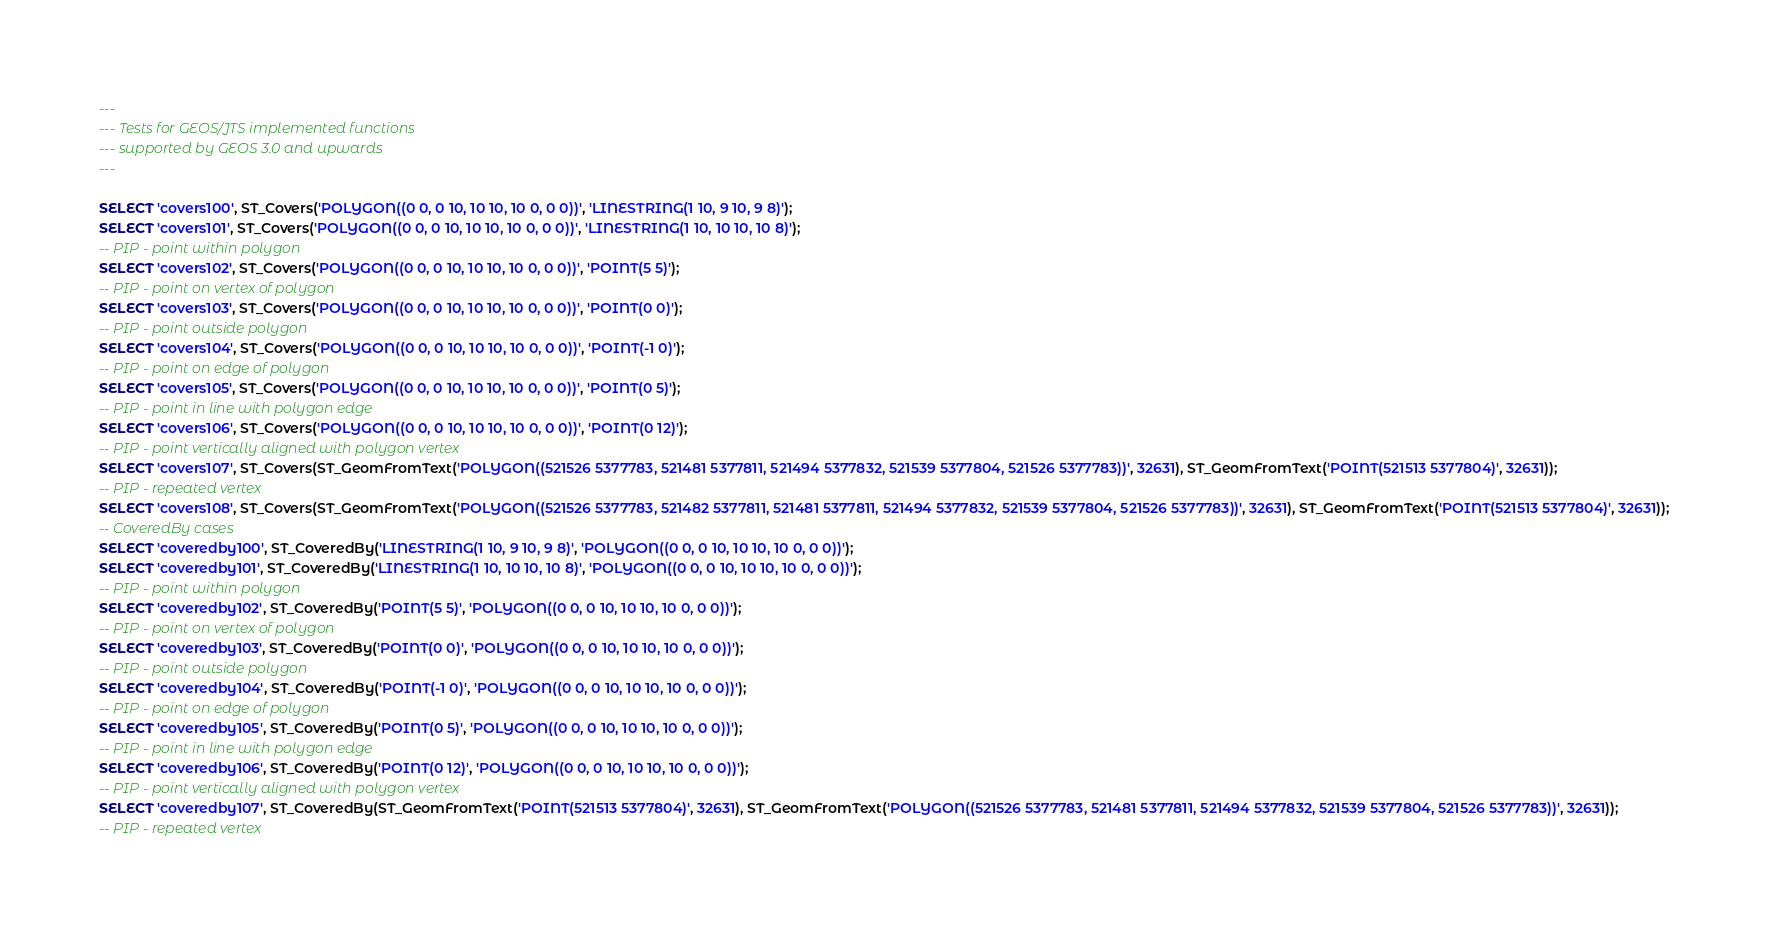Convert code to text. <code><loc_0><loc_0><loc_500><loc_500><_SQL_>---
--- Tests for GEOS/JTS implemented functions
--- supported by GEOS 3.0 and upwards
---

SELECT 'covers100', ST_Covers('POLYGON((0 0, 0 10, 10 10, 10 0, 0 0))', 'LINESTRING(1 10, 9 10, 9 8)');
SELECT 'covers101', ST_Covers('POLYGON((0 0, 0 10, 10 10, 10 0, 0 0))', 'LINESTRING(1 10, 10 10, 10 8)');
-- PIP - point within polygon
SELECT 'covers102', ST_Covers('POLYGON((0 0, 0 10, 10 10, 10 0, 0 0))', 'POINT(5 5)');
-- PIP - point on vertex of polygon
SELECT 'covers103', ST_Covers('POLYGON((0 0, 0 10, 10 10, 10 0, 0 0))', 'POINT(0 0)');
-- PIP - point outside polygon
SELECT 'covers104', ST_Covers('POLYGON((0 0, 0 10, 10 10, 10 0, 0 0))', 'POINT(-1 0)');
-- PIP - point on edge of polygon
SELECT 'covers105', ST_Covers('POLYGON((0 0, 0 10, 10 10, 10 0, 0 0))', 'POINT(0 5)');
-- PIP - point in line with polygon edge
SELECT 'covers106', ST_Covers('POLYGON((0 0, 0 10, 10 10, 10 0, 0 0))', 'POINT(0 12)');
-- PIP - point vertically aligned with polygon vertex 
SELECT 'covers107', ST_Covers(ST_GeomFromText('POLYGON((521526 5377783, 521481 5377811, 521494 5377832, 521539 5377804, 521526 5377783))', 32631), ST_GeomFromText('POINT(521513 5377804)', 32631));
-- PIP - repeated vertex 
SELECT 'covers108', ST_Covers(ST_GeomFromText('POLYGON((521526 5377783, 521482 5377811, 521481 5377811, 521494 5377832, 521539 5377804, 521526 5377783))', 32631), ST_GeomFromText('POINT(521513 5377804)', 32631));
-- CoveredBy cases
SELECT 'coveredby100', ST_CoveredBy('LINESTRING(1 10, 9 10, 9 8)', 'POLYGON((0 0, 0 10, 10 10, 10 0, 0 0))');
SELECT 'coveredby101', ST_CoveredBy('LINESTRING(1 10, 10 10, 10 8)', 'POLYGON((0 0, 0 10, 10 10, 10 0, 0 0))');
-- PIP - point within polygon
SELECT 'coveredby102', ST_CoveredBy('POINT(5 5)', 'POLYGON((0 0, 0 10, 10 10, 10 0, 0 0))');
-- PIP - point on vertex of polygon
SELECT 'coveredby103', ST_CoveredBy('POINT(0 0)', 'POLYGON((0 0, 0 10, 10 10, 10 0, 0 0))');
-- PIP - point outside polygon
SELECT 'coveredby104', ST_CoveredBy('POINT(-1 0)', 'POLYGON((0 0, 0 10, 10 10, 10 0, 0 0))');
-- PIP - point on edge of polygon
SELECT 'coveredby105', ST_CoveredBy('POINT(0 5)', 'POLYGON((0 0, 0 10, 10 10, 10 0, 0 0))');
-- PIP - point in line with polygon edge
SELECT 'coveredby106', ST_CoveredBy('POINT(0 12)', 'POLYGON((0 0, 0 10, 10 10, 10 0, 0 0))');
-- PIP - point vertically aligned with polygon vertex 
SELECT 'coveredby107', ST_CoveredBy(ST_GeomFromText('POINT(521513 5377804)', 32631), ST_GeomFromText('POLYGON((521526 5377783, 521481 5377811, 521494 5377832, 521539 5377804, 521526 5377783))', 32631));
-- PIP - repeated vertex </code> 